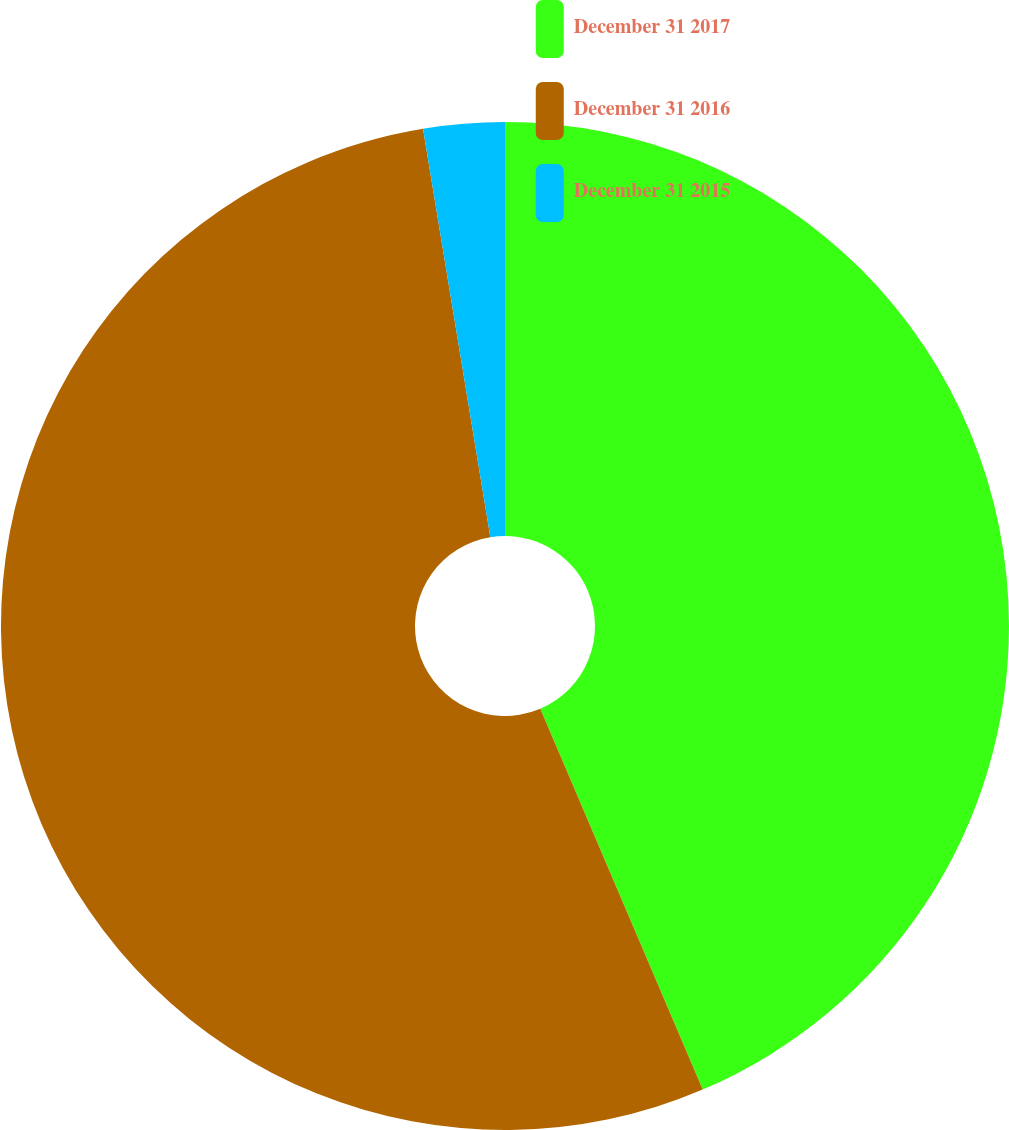Convert chart. <chart><loc_0><loc_0><loc_500><loc_500><pie_chart><fcel>December 31 2017<fcel>December 31 2016<fcel>December 31 2015<nl><fcel>43.58%<fcel>53.81%<fcel>2.6%<nl></chart> 